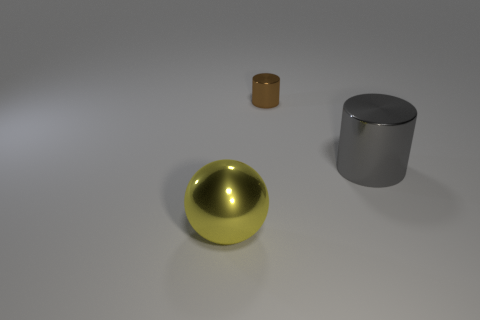Subtract all brown cylinders. How many cylinders are left? 1 Add 2 purple metal cylinders. How many objects exist? 5 Subtract all cylinders. How many objects are left? 1 Subtract all tiny green shiny balls. Subtract all yellow shiny things. How many objects are left? 2 Add 3 tiny metallic cylinders. How many tiny metallic cylinders are left? 4 Add 2 small brown shiny blocks. How many small brown shiny blocks exist? 2 Subtract 1 brown cylinders. How many objects are left? 2 Subtract 1 cylinders. How many cylinders are left? 1 Subtract all cyan cylinders. Subtract all brown blocks. How many cylinders are left? 2 Subtract all gray cylinders. How many purple balls are left? 0 